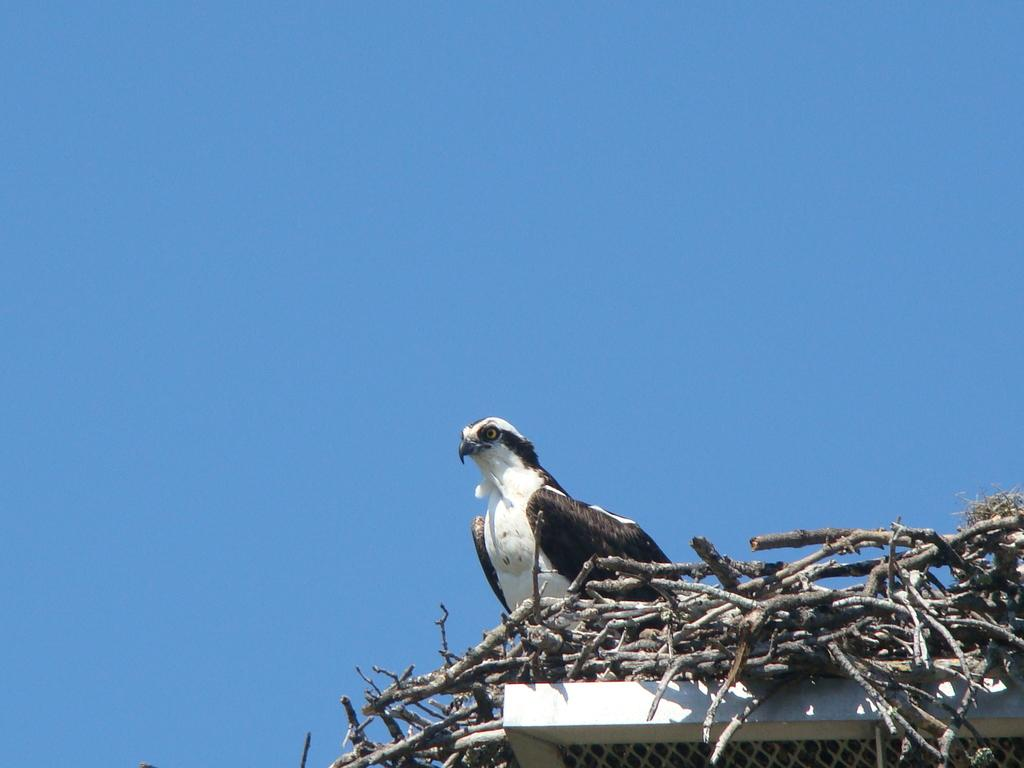What is located at the bottom of the image? There is a fence at the bottom of the image. What is attached to the fence? There are sticks on the fence. What type of animal can be seen on the fence? There is a bird on the fence. What is visible at the top of the image? The sky is visible at the top of the image. What type of feast is being prepared on the fence in the image? There is no feast being prepared in the image; it features a fence with sticks and a bird. Can you provide a receipt for the way the bird is perched on the fence in the image? There is no receipt for the bird's perching position on the fence, as it is a natural behavior and not a product or service. 